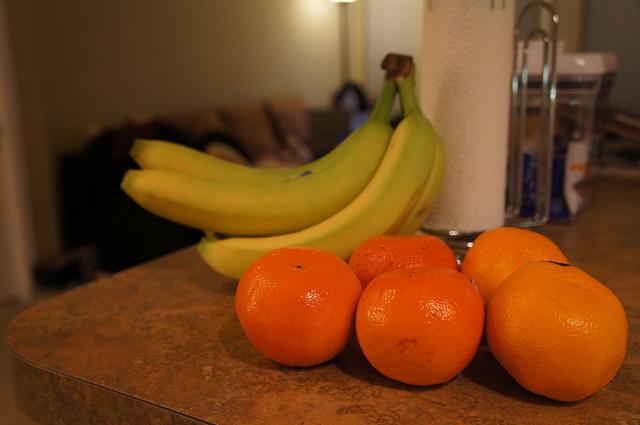Is there broccoli in this photo?
Concise answer only. No. What kind of vegetables are the color orange?
Be succinct. Carrots. What kind of food is this?
Short answer required. Fruit. Are the oranges spoiled?
Be succinct. No. Does the fruit look fresh?
Quick response, please. Yes. How many pineapples are there?
Keep it brief. 0. Why are there brown spots on the bananas?
Quick response, please. No. Are there any other fruits besides bananas on the table?
Concise answer only. Yes. 